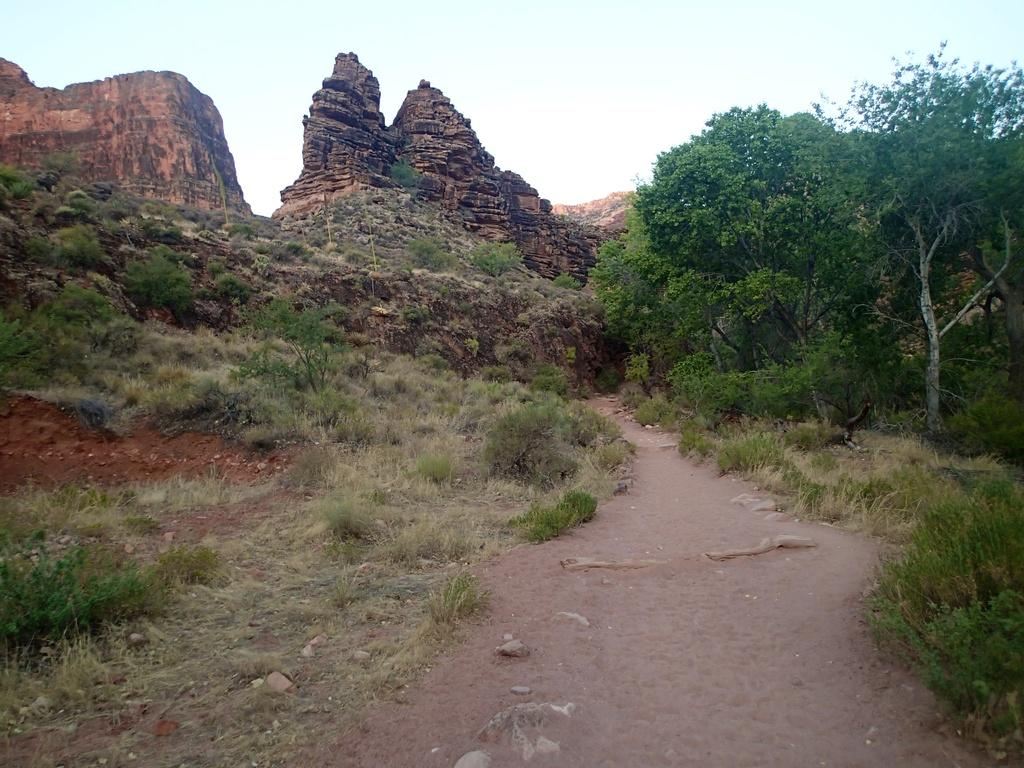What type of surface can be seen in the image? There is a path in the image. What type of vegetation is present in the image? Grass, plants, and trees are visible in the image. What other natural elements can be seen in the image? Rocks are in the image. What is visible in the background of the image? The sky is visible in the background of the image. What type of lamp can be seen hanging from the tree in the image? There is no lamp present in the image; it features a path, grass, plants, trees, rocks, and the sky. What type of animal can be seen interacting with the plants in the image? There is no animal present in the image; it only features plants, trees, rocks, and the sky. 